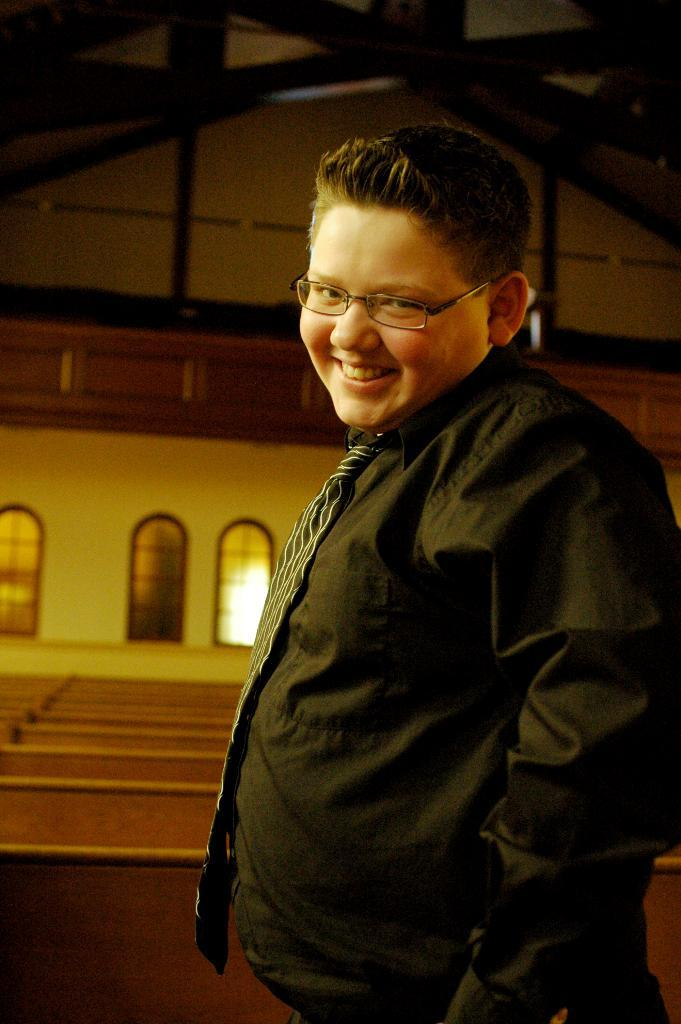What is the person in the image doing? The person is standing in the image and smiling. What can be seen in the background of the image? There are benches and windows in the background of the image. What type of chalk is the person holding in the image? There is no chalk present in the image. 